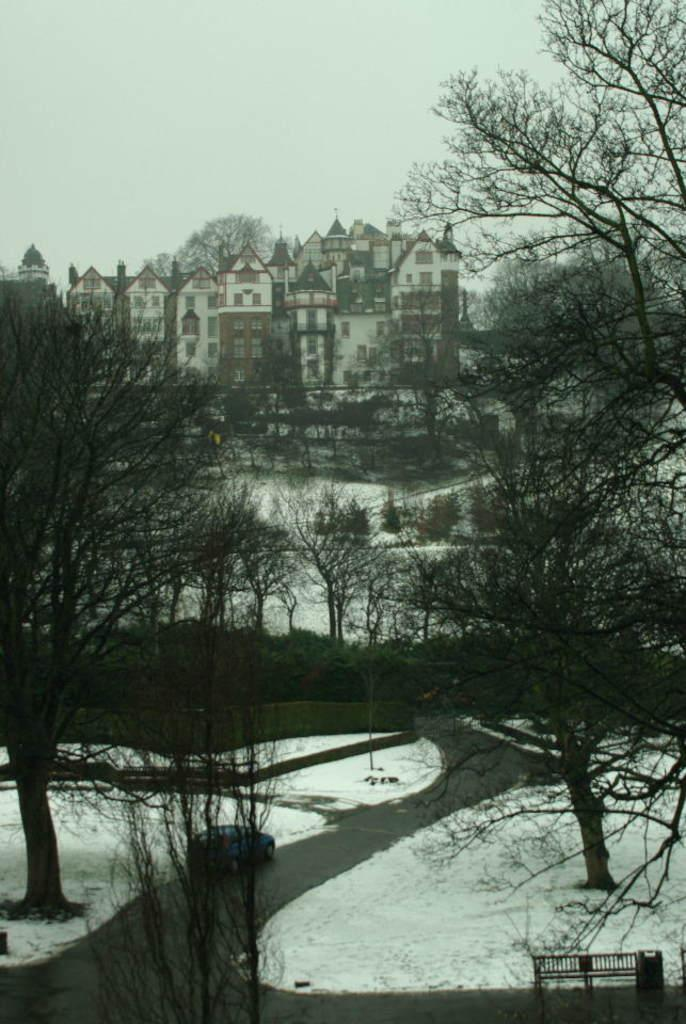What type of vegetation can be seen in the image? There are trees in the image. What type of structure is present in the image? There is a building in the image. What is covering the ground in the image? The ground is covered in snow. What mode of transportation can be seen in the image? There is a car visible in the image. What type of underwear is hanging on the trees in the image? There is no underwear present in the image; it only features trees, a building, snow-covered ground, and a car. Can you see a pin holding the snow together in the image? There is no pin visible in the image; it only shows trees, a building, snow-covered ground, and a car. 